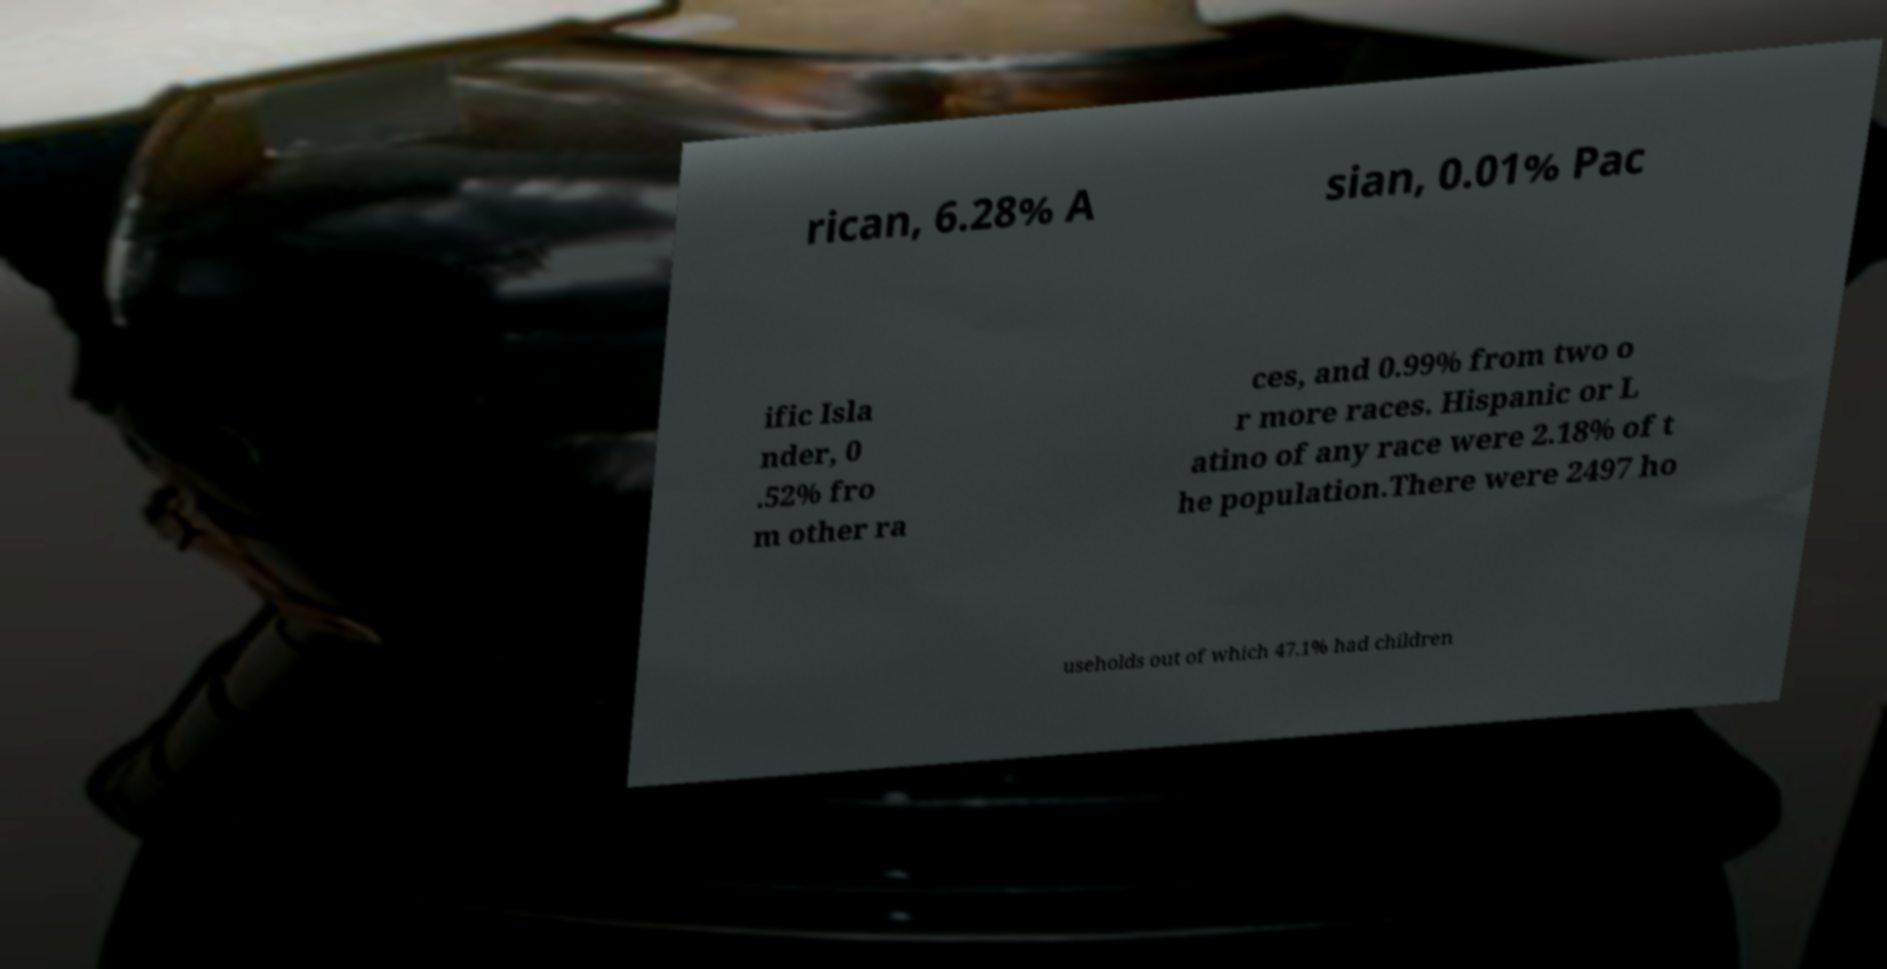Please read and relay the text visible in this image. What does it say? rican, 6.28% A sian, 0.01% Pac ific Isla nder, 0 .52% fro m other ra ces, and 0.99% from two o r more races. Hispanic or L atino of any race were 2.18% of t he population.There were 2497 ho useholds out of which 47.1% had children 